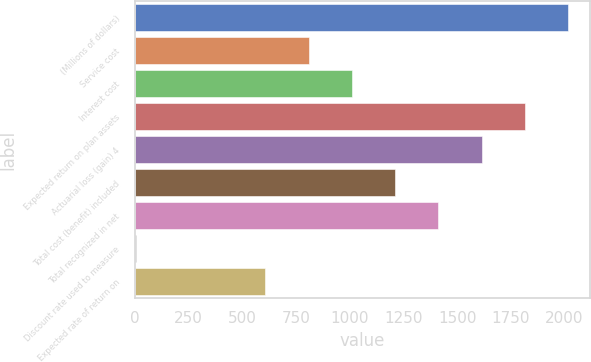Convert chart. <chart><loc_0><loc_0><loc_500><loc_500><bar_chart><fcel>(Millions of dollars)<fcel>Service cost<fcel>Interest cost<fcel>Expected return on plan assets<fcel>Actuarial loss (gain) 4<fcel>Total cost (benefit) included<fcel>Total recognized in net<fcel>Discount rate used to measure<fcel>Expected rate of return on<nl><fcel>2016<fcel>808.44<fcel>1009.7<fcel>1814.74<fcel>1613.48<fcel>1210.96<fcel>1412.22<fcel>3.4<fcel>607.18<nl></chart> 